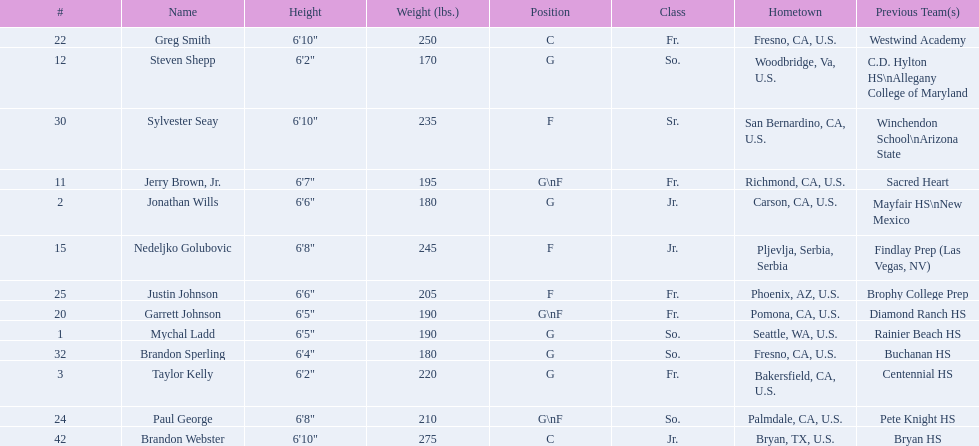Could you help me parse every detail presented in this table? {'header': ['#', 'Name', 'Height', 'Weight (lbs.)', 'Position', 'Class', 'Hometown', 'Previous Team(s)'], 'rows': [['22', 'Greg Smith', '6\'10"', '250', 'C', 'Fr.', 'Fresno, CA, U.S.', 'Westwind Academy'], ['12', 'Steven Shepp', '6\'2"', '170', 'G', 'So.', 'Woodbridge, Va, U.S.', 'C.D. Hylton HS\\nAllegany College of Maryland'], ['30', 'Sylvester Seay', '6\'10"', '235', 'F', 'Sr.', 'San Bernardino, CA, U.S.', 'Winchendon School\\nArizona State'], ['11', 'Jerry Brown, Jr.', '6\'7"', '195', 'G\\nF', 'Fr.', 'Richmond, CA, U.S.', 'Sacred Heart'], ['2', 'Jonathan Wills', '6\'6"', '180', 'G', 'Jr.', 'Carson, CA, U.S.', 'Mayfair HS\\nNew Mexico'], ['15', 'Nedeljko Golubovic', '6\'8"', '245', 'F', 'Jr.', 'Pljevlja, Serbia, Serbia', 'Findlay Prep (Las Vegas, NV)'], ['25', 'Justin Johnson', '6\'6"', '205', 'F', 'Fr.', 'Phoenix, AZ, U.S.', 'Brophy College Prep'], ['20', 'Garrett Johnson', '6\'5"', '190', 'G\\nF', 'Fr.', 'Pomona, CA, U.S.', 'Diamond Ranch HS'], ['1', 'Mychal Ladd', '6\'5"', '190', 'G', 'So.', 'Seattle, WA, U.S.', 'Rainier Beach HS'], ['32', 'Brandon Sperling', '6\'4"', '180', 'G', 'So.', 'Fresno, CA, U.S.', 'Buchanan HS'], ['3', 'Taylor Kelly', '6\'2"', '220', 'G', 'Fr.', 'Bakersfield, CA, U.S.', 'Centennial HS'], ['24', 'Paul George', '6\'8"', '210', 'G\\nF', 'So.', 'Palmdale, CA, U.S.', 'Pete Knight HS'], ['42', 'Brandon Webster', '6\'10"', '275', 'C', 'Jr.', 'Bryan, TX, U.S.', 'Bryan HS']]} What class was each team member in for the 2009-10 fresno state bulldogs? So., Jr., Fr., Fr., So., Jr., Fr., Fr., So., Fr., Sr., So., Jr. Which of these was outside of the us? Jr. Who was the player? Nedeljko Golubovic. 